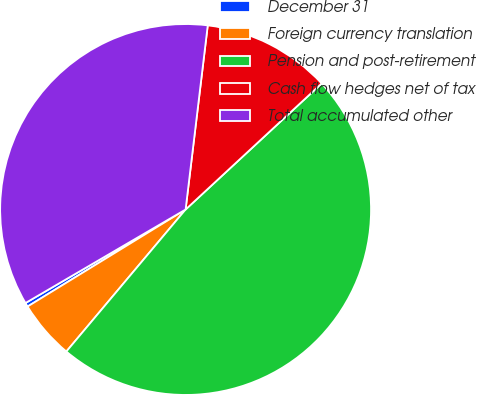Convert chart. <chart><loc_0><loc_0><loc_500><loc_500><pie_chart><fcel>December 31<fcel>Foreign currency translation<fcel>Pension and post-retirement<fcel>Cash flow hedges net of tax<fcel>Total accumulated other<nl><fcel>0.35%<fcel>5.12%<fcel>48.01%<fcel>11.2%<fcel>35.32%<nl></chart> 